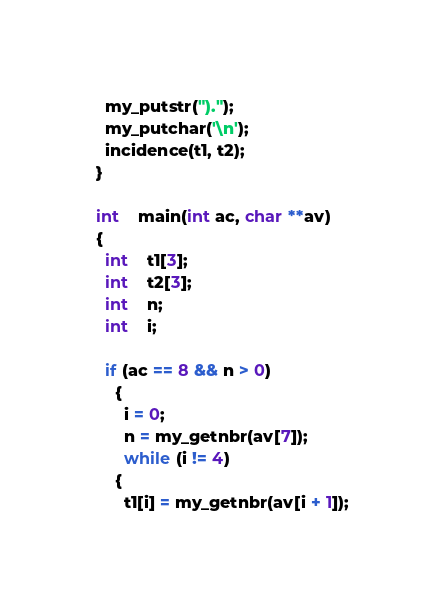Convert code to text. <code><loc_0><loc_0><loc_500><loc_500><_C_>  my_putstr(").");
  my_putchar('\n');
  incidence(t1, t2);
}

int	main(int ac, char **av)
{
  int	t1[3];
  int	t2[3];
  int	n;
  int	i;

  if (ac == 8 && n > 0)
    {
      i = 0;
      n = my_getnbr(av[7]);
      while (i != 4)
	{
	  t1[i] = my_getnbr(av[i + 1]);</code> 